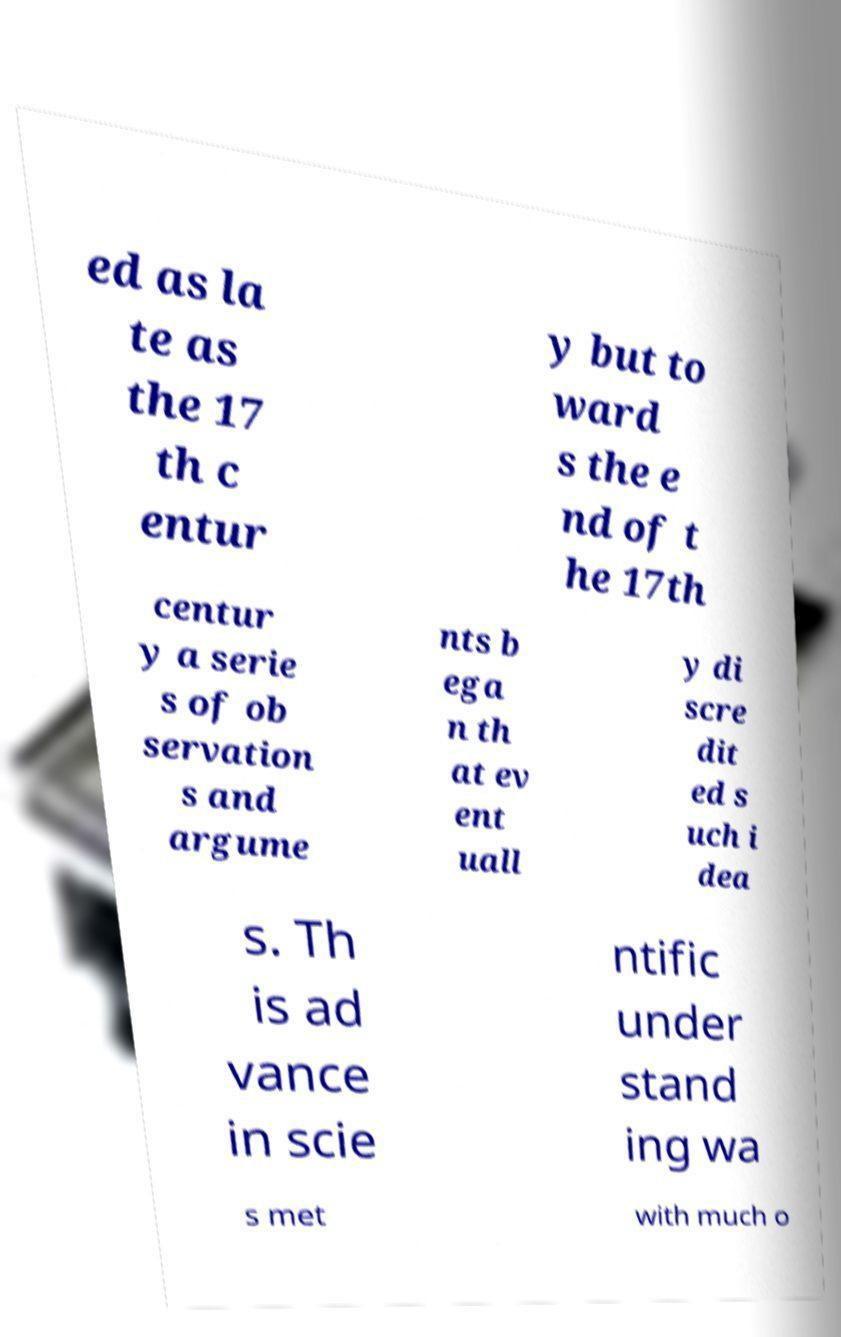What messages or text are displayed in this image? I need them in a readable, typed format. ed as la te as the 17 th c entur y but to ward s the e nd of t he 17th centur y a serie s of ob servation s and argume nts b ega n th at ev ent uall y di scre dit ed s uch i dea s. Th is ad vance in scie ntific under stand ing wa s met with much o 